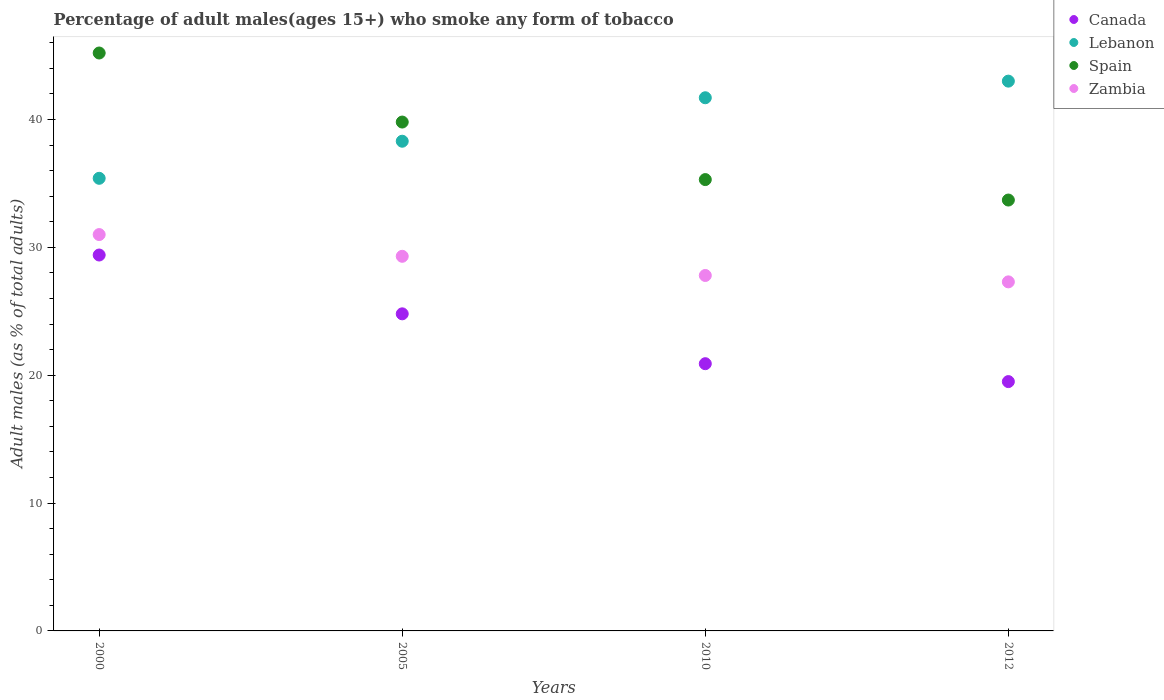How many different coloured dotlines are there?
Your answer should be compact. 4. Is the number of dotlines equal to the number of legend labels?
Your answer should be very brief. Yes. What is the percentage of adult males who smoke in Spain in 2005?
Offer a very short reply. 39.8. Across all years, what is the maximum percentage of adult males who smoke in Spain?
Your answer should be very brief. 45.2. In which year was the percentage of adult males who smoke in Lebanon maximum?
Provide a short and direct response. 2012. What is the total percentage of adult males who smoke in Spain in the graph?
Your answer should be very brief. 154. What is the difference between the percentage of adult males who smoke in Spain in 2000 and that in 2012?
Your answer should be compact. 11.5. What is the average percentage of adult males who smoke in Zambia per year?
Your answer should be very brief. 28.85. In the year 2012, what is the difference between the percentage of adult males who smoke in Zambia and percentage of adult males who smoke in Canada?
Your response must be concise. 7.8. In how many years, is the percentage of adult males who smoke in Zambia greater than 38 %?
Your answer should be very brief. 0. What is the ratio of the percentage of adult males who smoke in Spain in 2005 to that in 2012?
Ensure brevity in your answer.  1.18. What is the difference between the highest and the second highest percentage of adult males who smoke in Canada?
Give a very brief answer. 4.6. What is the difference between the highest and the lowest percentage of adult males who smoke in Lebanon?
Provide a succinct answer. 7.6. In how many years, is the percentage of adult males who smoke in Canada greater than the average percentage of adult males who smoke in Canada taken over all years?
Keep it short and to the point. 2. Is the sum of the percentage of adult males who smoke in Zambia in 2000 and 2010 greater than the maximum percentage of adult males who smoke in Spain across all years?
Offer a terse response. Yes. Is it the case that in every year, the sum of the percentage of adult males who smoke in Zambia and percentage of adult males who smoke in Lebanon  is greater than the percentage of adult males who smoke in Spain?
Give a very brief answer. Yes. Is the percentage of adult males who smoke in Zambia strictly greater than the percentage of adult males who smoke in Spain over the years?
Keep it short and to the point. No. Is the percentage of adult males who smoke in Zambia strictly less than the percentage of adult males who smoke in Canada over the years?
Make the answer very short. No. Are the values on the major ticks of Y-axis written in scientific E-notation?
Your response must be concise. No. Does the graph contain grids?
Offer a very short reply. No. How are the legend labels stacked?
Keep it short and to the point. Vertical. What is the title of the graph?
Give a very brief answer. Percentage of adult males(ages 15+) who smoke any form of tobacco. Does "Europe(developing only)" appear as one of the legend labels in the graph?
Offer a terse response. No. What is the label or title of the Y-axis?
Offer a terse response. Adult males (as % of total adults). What is the Adult males (as % of total adults) of Canada in 2000?
Offer a very short reply. 29.4. What is the Adult males (as % of total adults) in Lebanon in 2000?
Give a very brief answer. 35.4. What is the Adult males (as % of total adults) of Spain in 2000?
Offer a very short reply. 45.2. What is the Adult males (as % of total adults) of Zambia in 2000?
Your answer should be compact. 31. What is the Adult males (as % of total adults) of Canada in 2005?
Your response must be concise. 24.8. What is the Adult males (as % of total adults) of Lebanon in 2005?
Provide a succinct answer. 38.3. What is the Adult males (as % of total adults) of Spain in 2005?
Your response must be concise. 39.8. What is the Adult males (as % of total adults) in Zambia in 2005?
Make the answer very short. 29.3. What is the Adult males (as % of total adults) of Canada in 2010?
Give a very brief answer. 20.9. What is the Adult males (as % of total adults) of Lebanon in 2010?
Give a very brief answer. 41.7. What is the Adult males (as % of total adults) in Spain in 2010?
Provide a succinct answer. 35.3. What is the Adult males (as % of total adults) in Zambia in 2010?
Ensure brevity in your answer.  27.8. What is the Adult males (as % of total adults) in Canada in 2012?
Offer a terse response. 19.5. What is the Adult males (as % of total adults) in Spain in 2012?
Make the answer very short. 33.7. What is the Adult males (as % of total adults) in Zambia in 2012?
Keep it short and to the point. 27.3. Across all years, what is the maximum Adult males (as % of total adults) in Canada?
Give a very brief answer. 29.4. Across all years, what is the maximum Adult males (as % of total adults) of Lebanon?
Your answer should be compact. 43. Across all years, what is the maximum Adult males (as % of total adults) in Spain?
Keep it short and to the point. 45.2. Across all years, what is the maximum Adult males (as % of total adults) in Zambia?
Your answer should be very brief. 31. Across all years, what is the minimum Adult males (as % of total adults) in Canada?
Provide a short and direct response. 19.5. Across all years, what is the minimum Adult males (as % of total adults) in Lebanon?
Offer a very short reply. 35.4. Across all years, what is the minimum Adult males (as % of total adults) of Spain?
Ensure brevity in your answer.  33.7. Across all years, what is the minimum Adult males (as % of total adults) in Zambia?
Your answer should be very brief. 27.3. What is the total Adult males (as % of total adults) in Canada in the graph?
Make the answer very short. 94.6. What is the total Adult males (as % of total adults) in Lebanon in the graph?
Provide a succinct answer. 158.4. What is the total Adult males (as % of total adults) in Spain in the graph?
Make the answer very short. 154. What is the total Adult males (as % of total adults) of Zambia in the graph?
Offer a terse response. 115.4. What is the difference between the Adult males (as % of total adults) of Spain in 2000 and that in 2005?
Offer a very short reply. 5.4. What is the difference between the Adult males (as % of total adults) of Canada in 2000 and that in 2010?
Keep it short and to the point. 8.5. What is the difference between the Adult males (as % of total adults) of Lebanon in 2000 and that in 2010?
Your answer should be very brief. -6.3. What is the difference between the Adult males (as % of total adults) of Zambia in 2000 and that in 2010?
Give a very brief answer. 3.2. What is the difference between the Adult males (as % of total adults) of Lebanon in 2000 and that in 2012?
Make the answer very short. -7.6. What is the difference between the Adult males (as % of total adults) in Canada in 2005 and that in 2010?
Your answer should be compact. 3.9. What is the difference between the Adult males (as % of total adults) in Zambia in 2005 and that in 2010?
Keep it short and to the point. 1.5. What is the difference between the Adult males (as % of total adults) of Lebanon in 2005 and that in 2012?
Offer a very short reply. -4.7. What is the difference between the Adult males (as % of total adults) in Canada in 2010 and that in 2012?
Give a very brief answer. 1.4. What is the difference between the Adult males (as % of total adults) in Lebanon in 2010 and that in 2012?
Keep it short and to the point. -1.3. What is the difference between the Adult males (as % of total adults) of Canada in 2000 and the Adult males (as % of total adults) of Spain in 2005?
Make the answer very short. -10.4. What is the difference between the Adult males (as % of total adults) in Canada in 2000 and the Adult males (as % of total adults) in Zambia in 2005?
Ensure brevity in your answer.  0.1. What is the difference between the Adult males (as % of total adults) of Canada in 2000 and the Adult males (as % of total adults) of Zambia in 2010?
Your answer should be compact. 1.6. What is the difference between the Adult males (as % of total adults) in Lebanon in 2000 and the Adult males (as % of total adults) in Zambia in 2010?
Give a very brief answer. 7.6. What is the difference between the Adult males (as % of total adults) in Spain in 2000 and the Adult males (as % of total adults) in Zambia in 2010?
Offer a very short reply. 17.4. What is the difference between the Adult males (as % of total adults) in Canada in 2000 and the Adult males (as % of total adults) in Lebanon in 2012?
Your response must be concise. -13.6. What is the difference between the Adult males (as % of total adults) of Canada in 2000 and the Adult males (as % of total adults) of Spain in 2012?
Offer a very short reply. -4.3. What is the difference between the Adult males (as % of total adults) of Lebanon in 2000 and the Adult males (as % of total adults) of Spain in 2012?
Keep it short and to the point. 1.7. What is the difference between the Adult males (as % of total adults) in Lebanon in 2000 and the Adult males (as % of total adults) in Zambia in 2012?
Offer a terse response. 8.1. What is the difference between the Adult males (as % of total adults) in Spain in 2000 and the Adult males (as % of total adults) in Zambia in 2012?
Keep it short and to the point. 17.9. What is the difference between the Adult males (as % of total adults) in Canada in 2005 and the Adult males (as % of total adults) in Lebanon in 2010?
Offer a very short reply. -16.9. What is the difference between the Adult males (as % of total adults) in Lebanon in 2005 and the Adult males (as % of total adults) in Spain in 2010?
Offer a very short reply. 3. What is the difference between the Adult males (as % of total adults) in Canada in 2005 and the Adult males (as % of total adults) in Lebanon in 2012?
Your response must be concise. -18.2. What is the difference between the Adult males (as % of total adults) in Lebanon in 2005 and the Adult males (as % of total adults) in Zambia in 2012?
Offer a very short reply. 11. What is the difference between the Adult males (as % of total adults) in Canada in 2010 and the Adult males (as % of total adults) in Lebanon in 2012?
Offer a terse response. -22.1. What is the difference between the Adult males (as % of total adults) of Canada in 2010 and the Adult males (as % of total adults) of Spain in 2012?
Provide a short and direct response. -12.8. What is the difference between the Adult males (as % of total adults) in Lebanon in 2010 and the Adult males (as % of total adults) in Spain in 2012?
Offer a terse response. 8. What is the difference between the Adult males (as % of total adults) of Lebanon in 2010 and the Adult males (as % of total adults) of Zambia in 2012?
Provide a short and direct response. 14.4. What is the average Adult males (as % of total adults) in Canada per year?
Keep it short and to the point. 23.65. What is the average Adult males (as % of total adults) in Lebanon per year?
Your answer should be compact. 39.6. What is the average Adult males (as % of total adults) in Spain per year?
Offer a very short reply. 38.5. What is the average Adult males (as % of total adults) in Zambia per year?
Your response must be concise. 28.85. In the year 2000, what is the difference between the Adult males (as % of total adults) of Canada and Adult males (as % of total adults) of Spain?
Your answer should be very brief. -15.8. In the year 2000, what is the difference between the Adult males (as % of total adults) in Canada and Adult males (as % of total adults) in Zambia?
Give a very brief answer. -1.6. In the year 2000, what is the difference between the Adult males (as % of total adults) of Spain and Adult males (as % of total adults) of Zambia?
Ensure brevity in your answer.  14.2. In the year 2005, what is the difference between the Adult males (as % of total adults) in Canada and Adult males (as % of total adults) in Spain?
Make the answer very short. -15. In the year 2005, what is the difference between the Adult males (as % of total adults) of Lebanon and Adult males (as % of total adults) of Spain?
Your answer should be very brief. -1.5. In the year 2005, what is the difference between the Adult males (as % of total adults) in Spain and Adult males (as % of total adults) in Zambia?
Keep it short and to the point. 10.5. In the year 2010, what is the difference between the Adult males (as % of total adults) of Canada and Adult males (as % of total adults) of Lebanon?
Provide a succinct answer. -20.8. In the year 2010, what is the difference between the Adult males (as % of total adults) of Canada and Adult males (as % of total adults) of Spain?
Provide a succinct answer. -14.4. In the year 2010, what is the difference between the Adult males (as % of total adults) of Lebanon and Adult males (as % of total adults) of Zambia?
Provide a short and direct response. 13.9. In the year 2012, what is the difference between the Adult males (as % of total adults) of Canada and Adult males (as % of total adults) of Lebanon?
Give a very brief answer. -23.5. What is the ratio of the Adult males (as % of total adults) of Canada in 2000 to that in 2005?
Ensure brevity in your answer.  1.19. What is the ratio of the Adult males (as % of total adults) of Lebanon in 2000 to that in 2005?
Offer a very short reply. 0.92. What is the ratio of the Adult males (as % of total adults) in Spain in 2000 to that in 2005?
Your response must be concise. 1.14. What is the ratio of the Adult males (as % of total adults) of Zambia in 2000 to that in 2005?
Keep it short and to the point. 1.06. What is the ratio of the Adult males (as % of total adults) in Canada in 2000 to that in 2010?
Your answer should be very brief. 1.41. What is the ratio of the Adult males (as % of total adults) in Lebanon in 2000 to that in 2010?
Give a very brief answer. 0.85. What is the ratio of the Adult males (as % of total adults) of Spain in 2000 to that in 2010?
Make the answer very short. 1.28. What is the ratio of the Adult males (as % of total adults) of Zambia in 2000 to that in 2010?
Keep it short and to the point. 1.12. What is the ratio of the Adult males (as % of total adults) in Canada in 2000 to that in 2012?
Offer a terse response. 1.51. What is the ratio of the Adult males (as % of total adults) of Lebanon in 2000 to that in 2012?
Your response must be concise. 0.82. What is the ratio of the Adult males (as % of total adults) of Spain in 2000 to that in 2012?
Keep it short and to the point. 1.34. What is the ratio of the Adult males (as % of total adults) in Zambia in 2000 to that in 2012?
Your response must be concise. 1.14. What is the ratio of the Adult males (as % of total adults) in Canada in 2005 to that in 2010?
Make the answer very short. 1.19. What is the ratio of the Adult males (as % of total adults) in Lebanon in 2005 to that in 2010?
Your answer should be very brief. 0.92. What is the ratio of the Adult males (as % of total adults) in Spain in 2005 to that in 2010?
Ensure brevity in your answer.  1.13. What is the ratio of the Adult males (as % of total adults) of Zambia in 2005 to that in 2010?
Offer a terse response. 1.05. What is the ratio of the Adult males (as % of total adults) in Canada in 2005 to that in 2012?
Your answer should be compact. 1.27. What is the ratio of the Adult males (as % of total adults) of Lebanon in 2005 to that in 2012?
Provide a short and direct response. 0.89. What is the ratio of the Adult males (as % of total adults) of Spain in 2005 to that in 2012?
Your answer should be compact. 1.18. What is the ratio of the Adult males (as % of total adults) of Zambia in 2005 to that in 2012?
Offer a very short reply. 1.07. What is the ratio of the Adult males (as % of total adults) in Canada in 2010 to that in 2012?
Your answer should be very brief. 1.07. What is the ratio of the Adult males (as % of total adults) of Lebanon in 2010 to that in 2012?
Offer a terse response. 0.97. What is the ratio of the Adult males (as % of total adults) of Spain in 2010 to that in 2012?
Your response must be concise. 1.05. What is the ratio of the Adult males (as % of total adults) of Zambia in 2010 to that in 2012?
Offer a terse response. 1.02. What is the difference between the highest and the second highest Adult males (as % of total adults) of Lebanon?
Ensure brevity in your answer.  1.3. What is the difference between the highest and the second highest Adult males (as % of total adults) of Zambia?
Provide a short and direct response. 1.7. What is the difference between the highest and the lowest Adult males (as % of total adults) in Canada?
Your response must be concise. 9.9. 